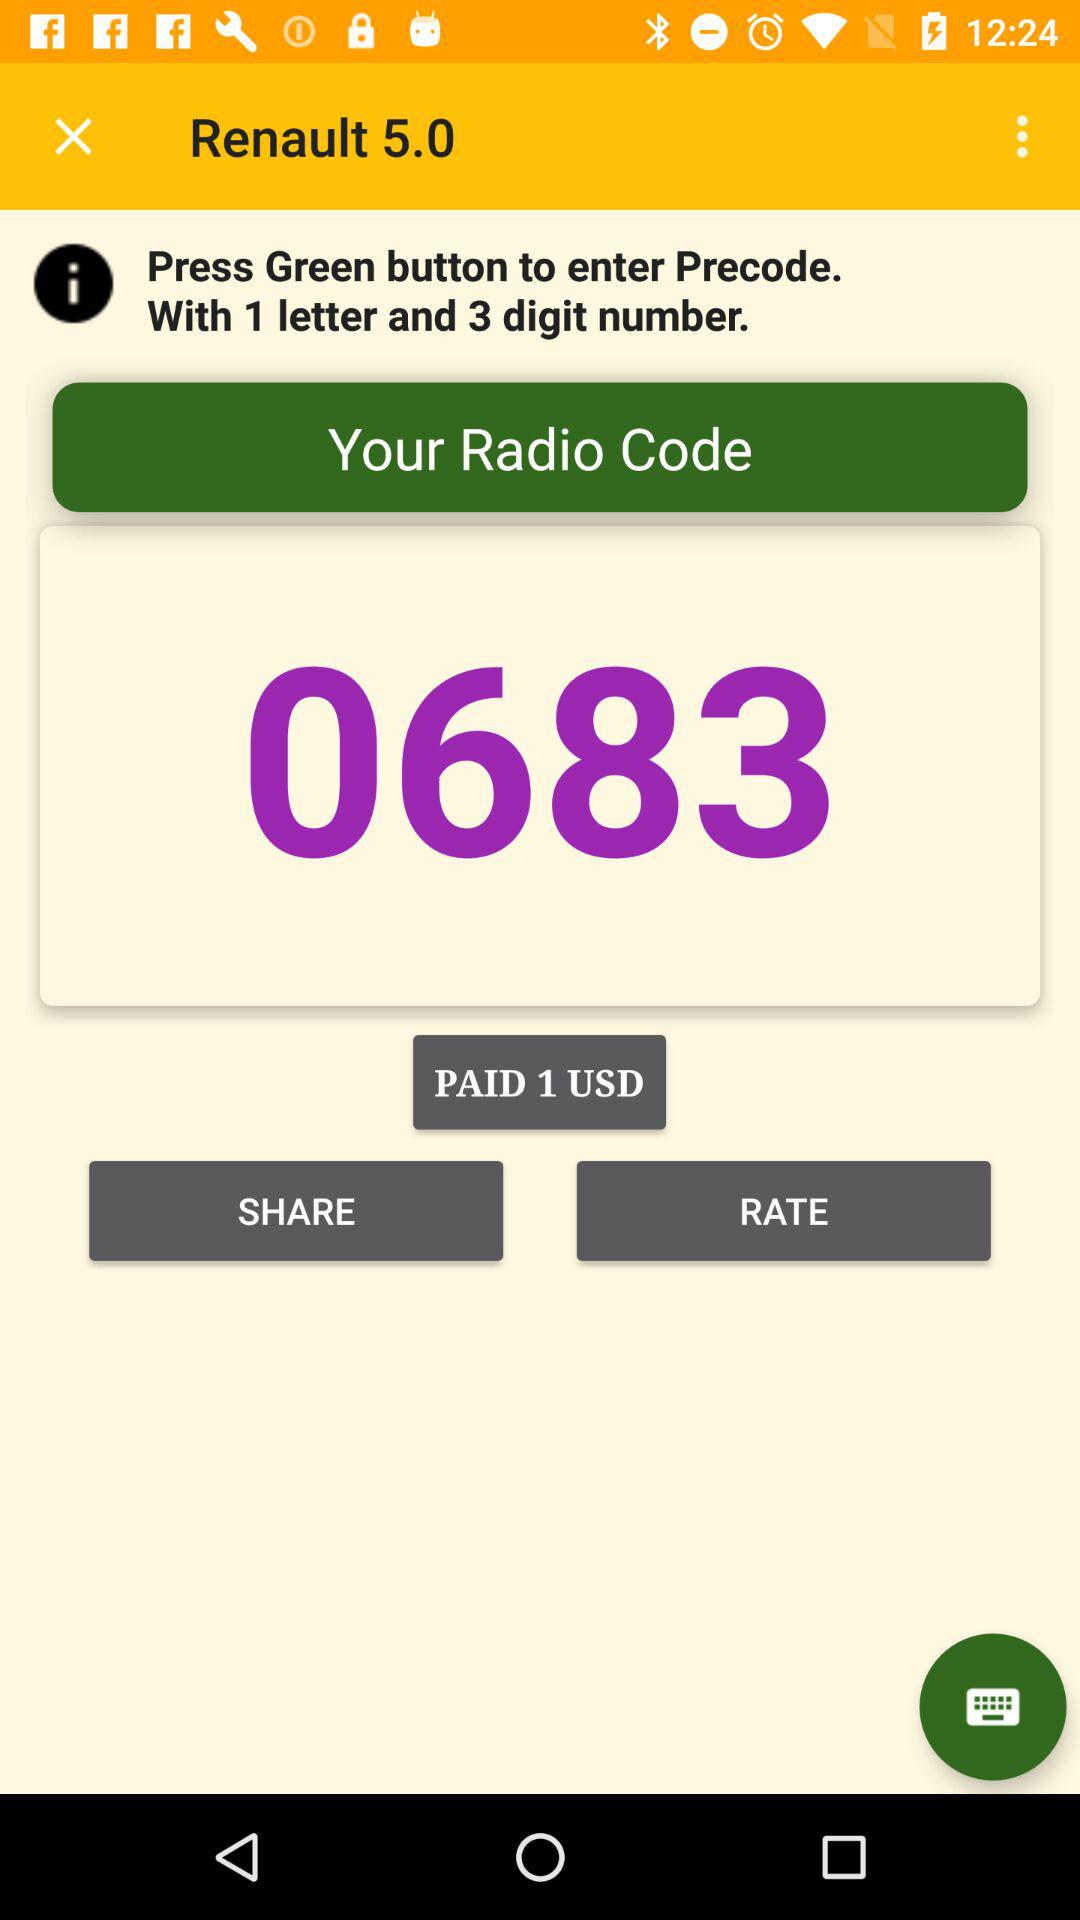How much was paid? The amount of 1 USD was paid. 